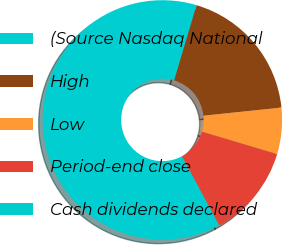<chart> <loc_0><loc_0><loc_500><loc_500><pie_chart><fcel>(Source Nasdaq National<fcel>High<fcel>Low<fcel>Period-end close<fcel>Cash dividends declared<nl><fcel>62.48%<fcel>18.75%<fcel>6.26%<fcel>12.5%<fcel>0.01%<nl></chart> 